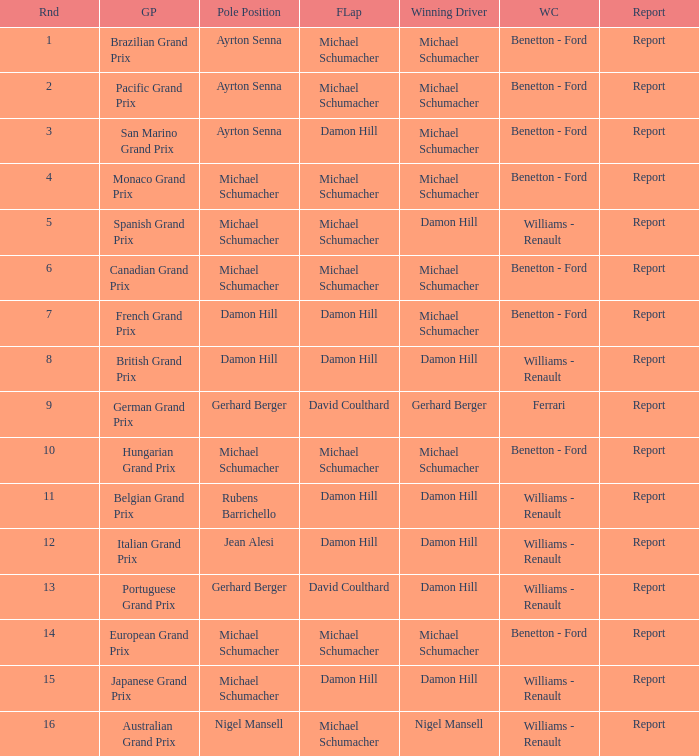Name the lowest round for when pole position and winning driver is michael schumacher 4.0. 